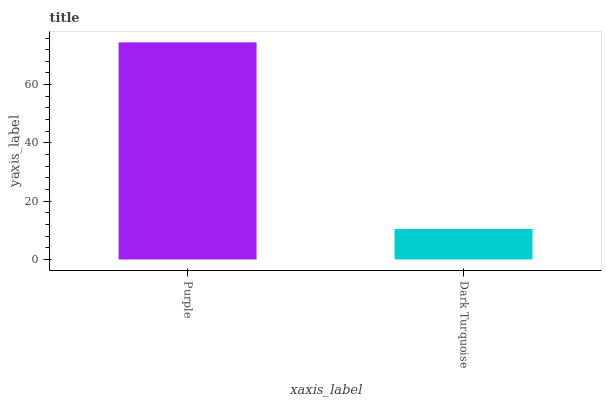Is Dark Turquoise the minimum?
Answer yes or no. Yes. Is Purple the maximum?
Answer yes or no. Yes. Is Dark Turquoise the maximum?
Answer yes or no. No. Is Purple greater than Dark Turquoise?
Answer yes or no. Yes. Is Dark Turquoise less than Purple?
Answer yes or no. Yes. Is Dark Turquoise greater than Purple?
Answer yes or no. No. Is Purple less than Dark Turquoise?
Answer yes or no. No. Is Purple the high median?
Answer yes or no. Yes. Is Dark Turquoise the low median?
Answer yes or no. Yes. Is Dark Turquoise the high median?
Answer yes or no. No. Is Purple the low median?
Answer yes or no. No. 